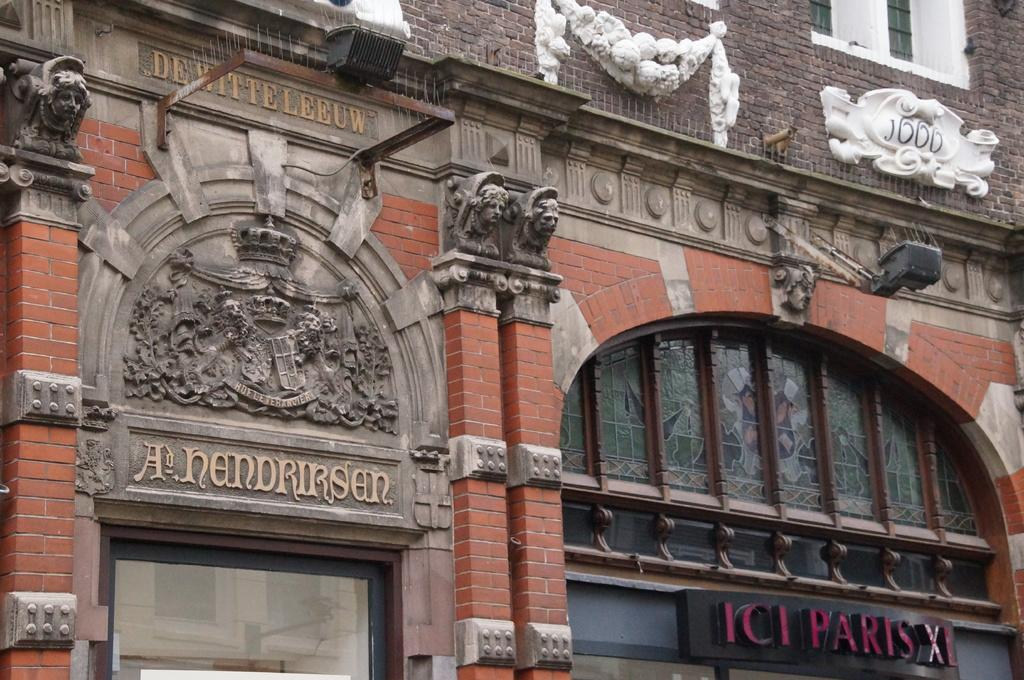What type of structures are present in the image? There are stalls in the image. Can you describe the color of one of the buildings in the image? There is a building with a brown color in the image. What type of object can be seen providing light in the image? There is a light pole in the image. What architectural feature can be seen on the buildings in the image? There are windows visible in the image. Where is the swing located in the image? There is no swing present in the image. Can you see any apples hanging from the trees in the image? There are no trees or apples visible in the image. 